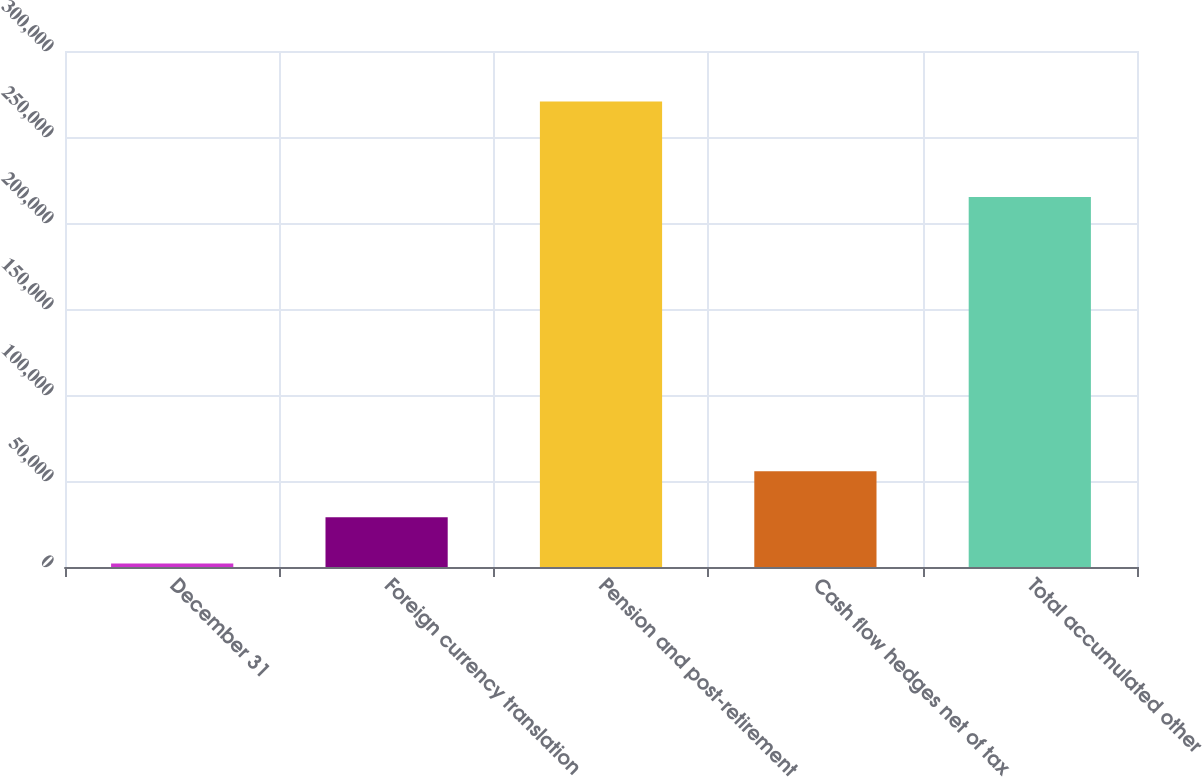Convert chart. <chart><loc_0><loc_0><loc_500><loc_500><bar_chart><fcel>December 31<fcel>Foreign currency translation<fcel>Pension and post-retirement<fcel>Cash flow hedges net of tax<fcel>Total accumulated other<nl><fcel>2010<fcel>28867<fcel>270580<fcel>55724<fcel>215067<nl></chart> 